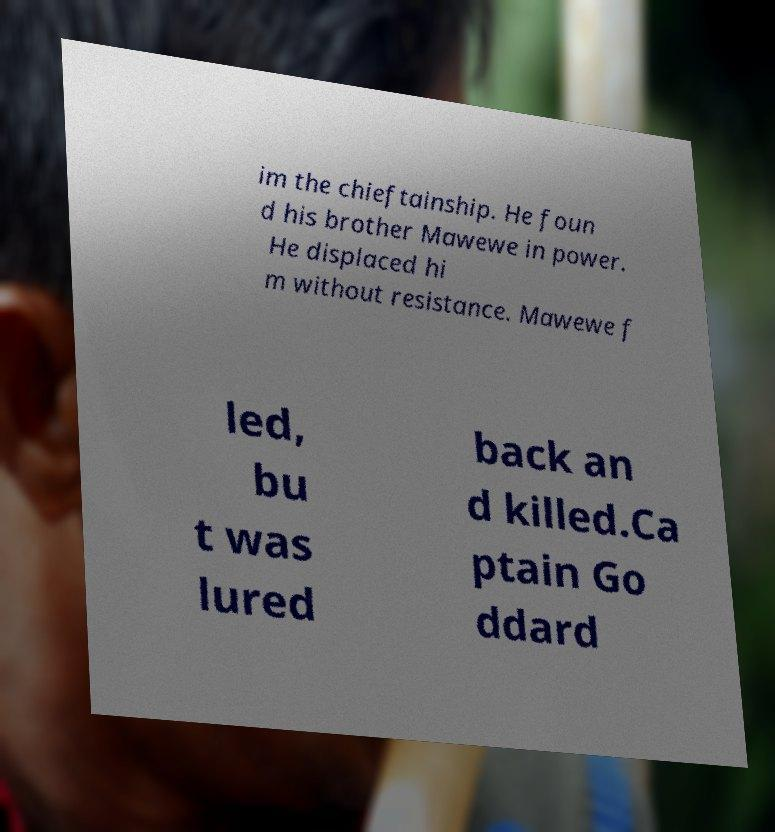Please read and relay the text visible in this image. What does it say? im the chieftainship. He foun d his brother Mawewe in power. He displaced hi m without resistance. Mawewe f led, bu t was lured back an d killed.Ca ptain Go ddard 